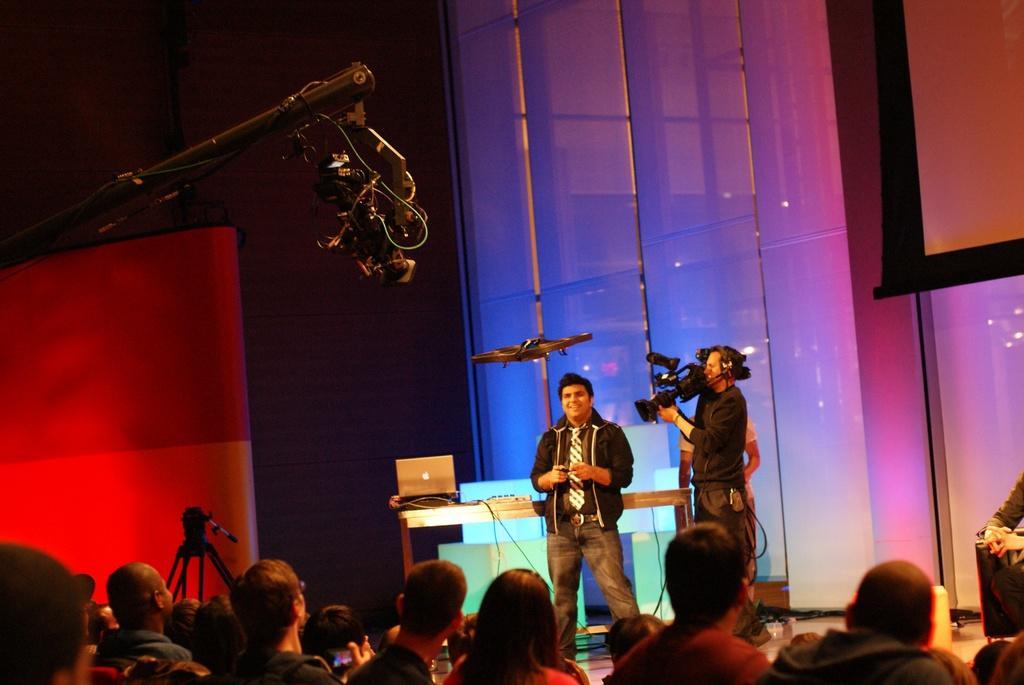How would you summarize this image in a sentence or two? In the picture we can see two people are standing on the stage one man is holding a camera and shooting another man and beside him we can see a table on it we can see a laptop and some wires and beside the table we can see a tripod and in front of the man we can see some people are standing and watching them and in the background we can see a wall with a glass and blue color light focus on it and we can see some part of red in color. 